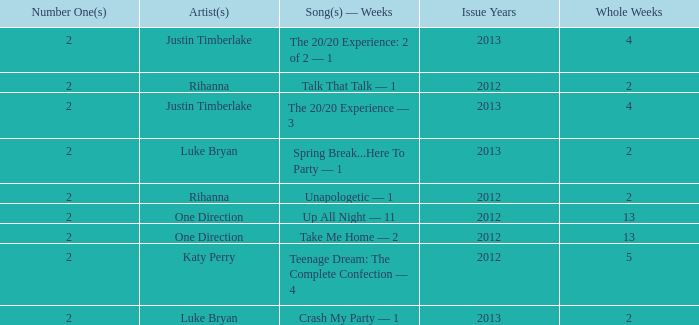What is the title of every song, and how many weeks was each song at #1 for Rihanna in 2012? Talk That Talk — 1, Unapologetic — 1. 